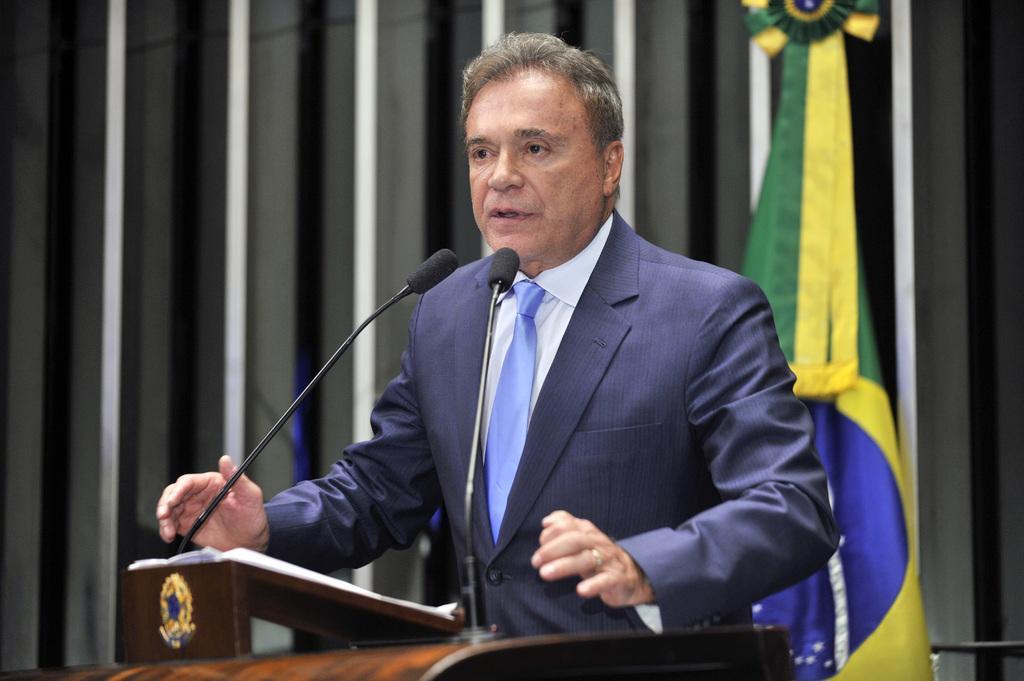Can you describe this image briefly? In the center of the image we can see a man standing, before him there is a podium and we can see papers and mics placed on the podium. In the background there is a flag and a curtain. 